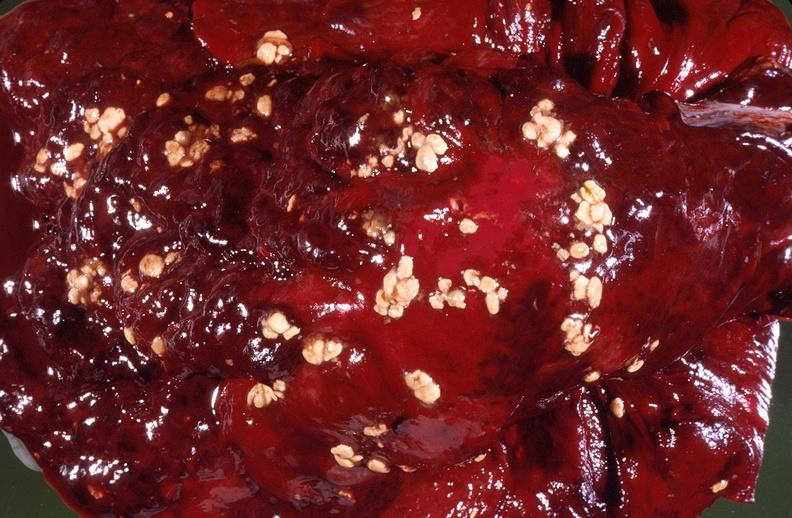where is this?
Answer the question using a single word or phrase. Lung 